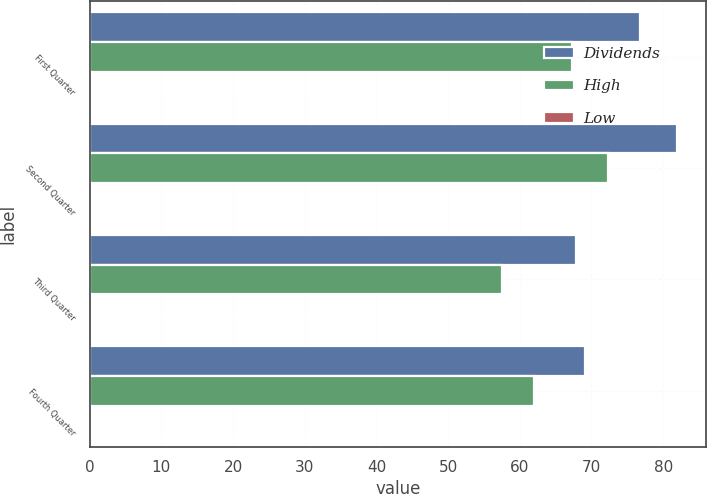<chart> <loc_0><loc_0><loc_500><loc_500><stacked_bar_chart><ecel><fcel>First Quarter<fcel>Second Quarter<fcel>Third Quarter<fcel>Fourth Quarter<nl><fcel>Dividends<fcel>76.75<fcel>81.92<fcel>67.9<fcel>69.09<nl><fcel>High<fcel>67.34<fcel>72.31<fcel>57.46<fcel>61.97<nl><fcel>Low<fcel>0.2<fcel>0.2<fcel>0.18<fcel>0.18<nl></chart> 